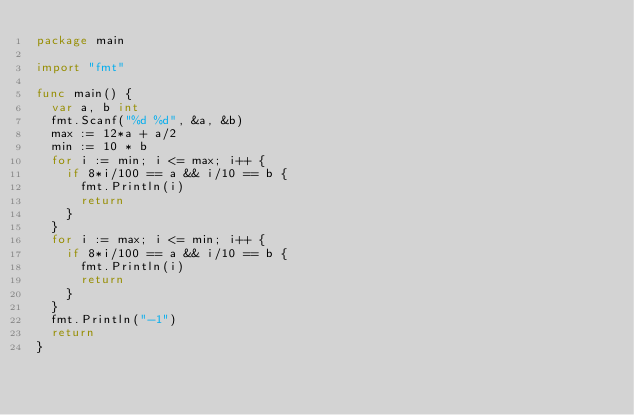Convert code to text. <code><loc_0><loc_0><loc_500><loc_500><_Go_>package main

import "fmt"

func main() {
	var a, b int
	fmt.Scanf("%d %d", &a, &b)
	max := 12*a + a/2
	min := 10 * b
	for i := min; i <= max; i++ {
		if 8*i/100 == a && i/10 == b {
			fmt.Println(i)
			return
		}
	}
	for i := max; i <= min; i++ {
		if 8*i/100 == a && i/10 == b {
			fmt.Println(i)
			return
		}
	}
	fmt.Println("-1")
	return
}
</code> 